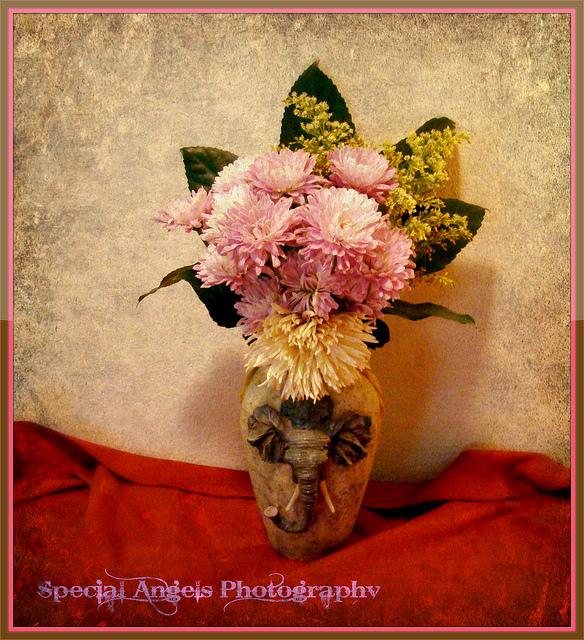What animal is represented in the photo?
Quick response, please. Elephant. What color are the flowers?
Answer briefly. Pink and yellow. What color is the cloth the flowers are on?
Give a very brief answer. Red. 